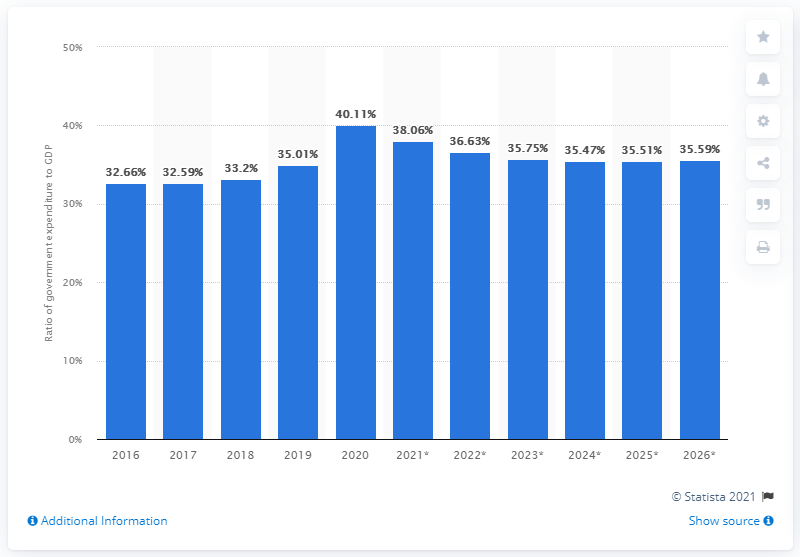Mention a couple of crucial points in this snapshot. In 2020, government expenditure accounted for 40.11% of South Africa's GDP. 